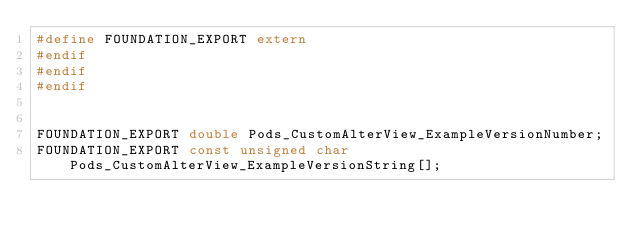<code> <loc_0><loc_0><loc_500><loc_500><_C_>#define FOUNDATION_EXPORT extern
#endif
#endif
#endif


FOUNDATION_EXPORT double Pods_CustomAlterView_ExampleVersionNumber;
FOUNDATION_EXPORT const unsigned char Pods_CustomAlterView_ExampleVersionString[];

</code> 